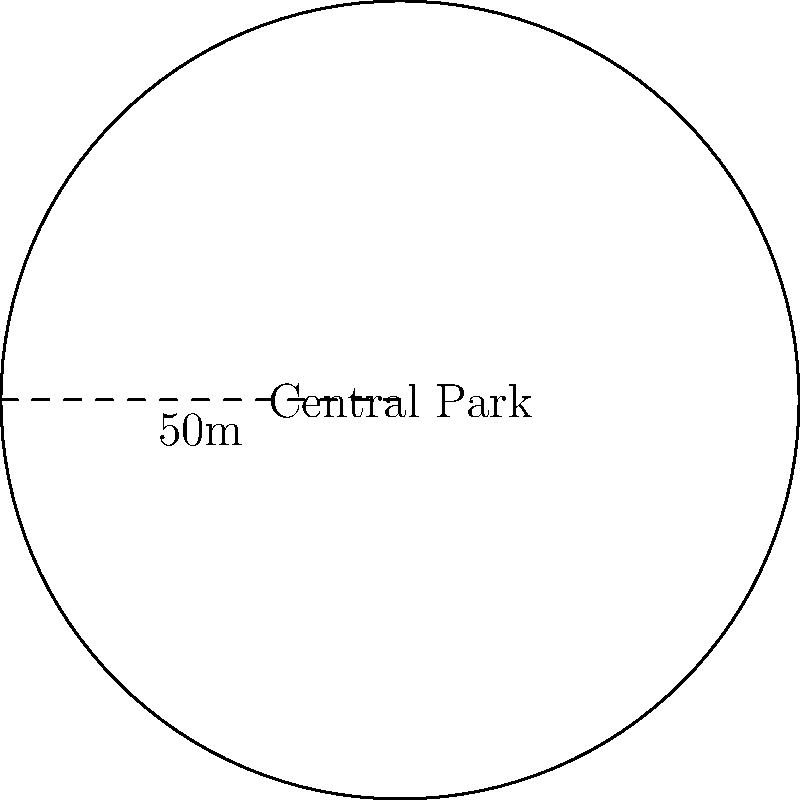As the city's mayor, you're responsible for allocating funds for park maintenance. Central Park, a circular green space in the heart of the city, requires annual upkeep. If the park's radius is 50 meters and the maintenance cost is $2 per square meter, what would be the total annual budget needed for the park's upkeep? To solve this problem, we need to follow these steps:

1. Calculate the area of the circular park:
   The formula for the area of a circle is $A = \pi r^2$, where $r$ is the radius.
   
   $A = \pi \times 50^2 = 2500\pi$ square meters

2. Calculate the maintenance cost:
   The cost per square meter is $2, so we multiply the area by 2.
   
   Total cost = $2500\pi \times 2 = 5000\pi$ dollars

3. Round the result to a practical budget figure:
   $5000\pi \approx 15,707.96$ dollars

Therefore, the annual budget needed for the park's upkeep would be approximately $15,708.
Answer: $15,708 